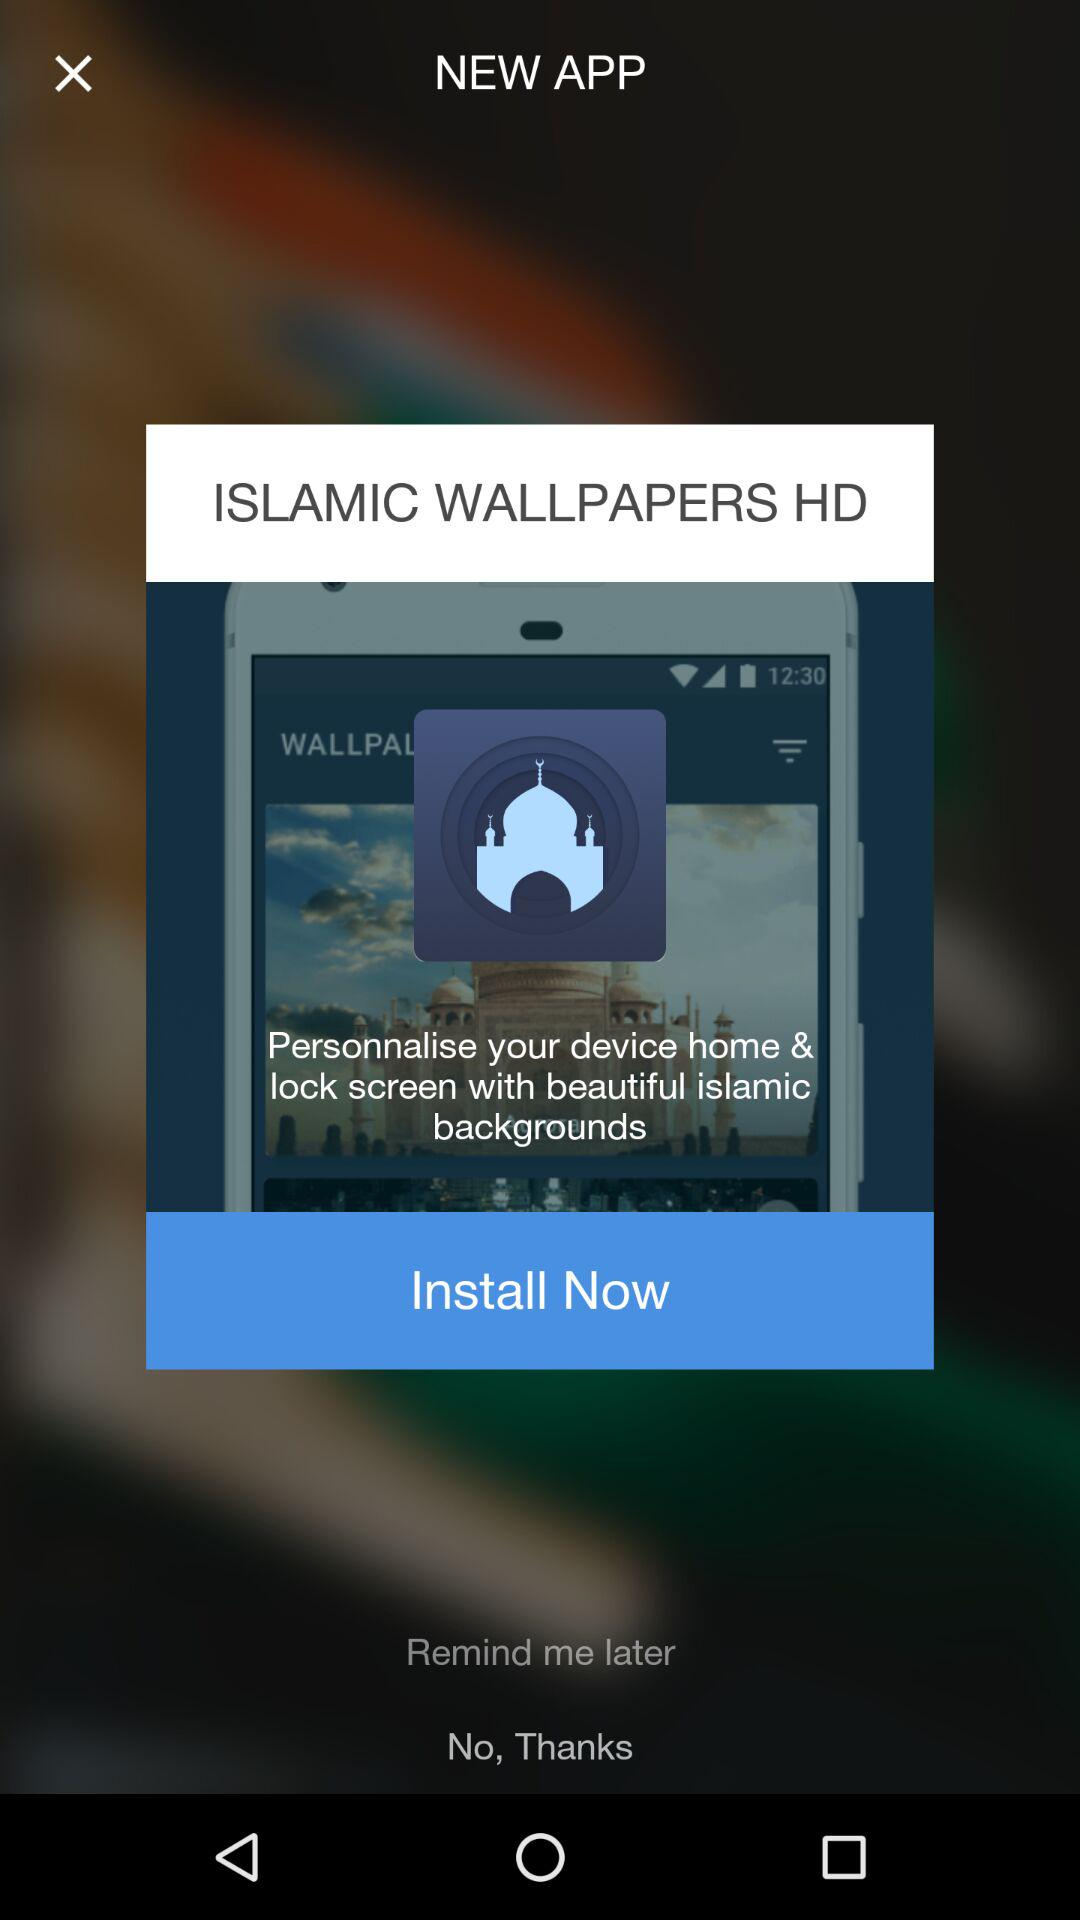What is the app name? The app name is "ISLAMIC WALLPAPERS HD". 